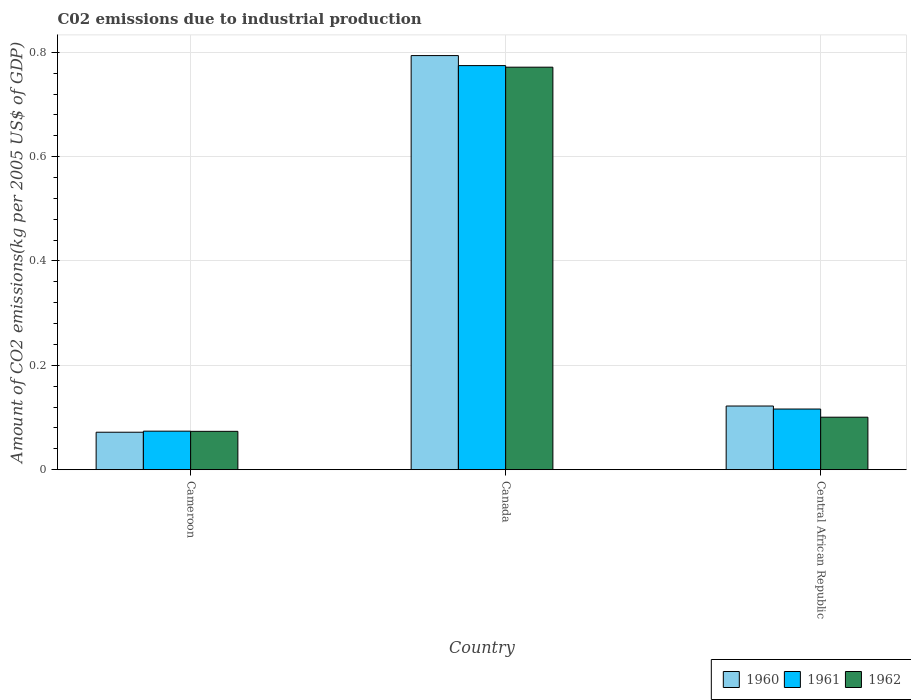How many different coloured bars are there?
Keep it short and to the point. 3. How many groups of bars are there?
Give a very brief answer. 3. How many bars are there on the 2nd tick from the right?
Offer a very short reply. 3. What is the label of the 1st group of bars from the left?
Your answer should be very brief. Cameroon. What is the amount of CO2 emitted due to industrial production in 1961 in Canada?
Your answer should be very brief. 0.77. Across all countries, what is the maximum amount of CO2 emitted due to industrial production in 1961?
Your answer should be compact. 0.77. Across all countries, what is the minimum amount of CO2 emitted due to industrial production in 1962?
Ensure brevity in your answer.  0.07. In which country was the amount of CO2 emitted due to industrial production in 1960 maximum?
Keep it short and to the point. Canada. In which country was the amount of CO2 emitted due to industrial production in 1962 minimum?
Your answer should be very brief. Cameroon. What is the total amount of CO2 emitted due to industrial production in 1961 in the graph?
Provide a short and direct response. 0.96. What is the difference between the amount of CO2 emitted due to industrial production in 1960 in Canada and that in Central African Republic?
Your answer should be compact. 0.67. What is the difference between the amount of CO2 emitted due to industrial production in 1962 in Central African Republic and the amount of CO2 emitted due to industrial production in 1960 in Canada?
Keep it short and to the point. -0.69. What is the average amount of CO2 emitted due to industrial production in 1961 per country?
Your answer should be compact. 0.32. What is the difference between the amount of CO2 emitted due to industrial production of/in 1960 and amount of CO2 emitted due to industrial production of/in 1961 in Central African Republic?
Offer a terse response. 0.01. In how many countries, is the amount of CO2 emitted due to industrial production in 1960 greater than 0.7200000000000001 kg?
Make the answer very short. 1. What is the ratio of the amount of CO2 emitted due to industrial production in 1960 in Cameroon to that in Central African Republic?
Offer a terse response. 0.59. What is the difference between the highest and the second highest amount of CO2 emitted due to industrial production in 1962?
Offer a very short reply. 0.7. What is the difference between the highest and the lowest amount of CO2 emitted due to industrial production in 1961?
Offer a terse response. 0.7. What does the 2nd bar from the left in Cameroon represents?
Give a very brief answer. 1961. What does the 1st bar from the right in Central African Republic represents?
Give a very brief answer. 1962. Are all the bars in the graph horizontal?
Offer a terse response. No. How many countries are there in the graph?
Offer a terse response. 3. What is the difference between two consecutive major ticks on the Y-axis?
Offer a very short reply. 0.2. Are the values on the major ticks of Y-axis written in scientific E-notation?
Keep it short and to the point. No. Does the graph contain any zero values?
Provide a short and direct response. No. Does the graph contain grids?
Your answer should be very brief. Yes. What is the title of the graph?
Your response must be concise. C02 emissions due to industrial production. What is the label or title of the Y-axis?
Provide a short and direct response. Amount of CO2 emissions(kg per 2005 US$ of GDP). What is the Amount of CO2 emissions(kg per 2005 US$ of GDP) of 1960 in Cameroon?
Offer a very short reply. 0.07. What is the Amount of CO2 emissions(kg per 2005 US$ of GDP) of 1961 in Cameroon?
Offer a very short reply. 0.07. What is the Amount of CO2 emissions(kg per 2005 US$ of GDP) in 1962 in Cameroon?
Ensure brevity in your answer.  0.07. What is the Amount of CO2 emissions(kg per 2005 US$ of GDP) in 1960 in Canada?
Keep it short and to the point. 0.79. What is the Amount of CO2 emissions(kg per 2005 US$ of GDP) in 1961 in Canada?
Ensure brevity in your answer.  0.77. What is the Amount of CO2 emissions(kg per 2005 US$ of GDP) of 1962 in Canada?
Ensure brevity in your answer.  0.77. What is the Amount of CO2 emissions(kg per 2005 US$ of GDP) in 1960 in Central African Republic?
Your answer should be very brief. 0.12. What is the Amount of CO2 emissions(kg per 2005 US$ of GDP) of 1961 in Central African Republic?
Ensure brevity in your answer.  0.12. What is the Amount of CO2 emissions(kg per 2005 US$ of GDP) of 1962 in Central African Republic?
Provide a succinct answer. 0.1. Across all countries, what is the maximum Amount of CO2 emissions(kg per 2005 US$ of GDP) in 1960?
Make the answer very short. 0.79. Across all countries, what is the maximum Amount of CO2 emissions(kg per 2005 US$ of GDP) in 1961?
Your answer should be very brief. 0.77. Across all countries, what is the maximum Amount of CO2 emissions(kg per 2005 US$ of GDP) of 1962?
Provide a succinct answer. 0.77. Across all countries, what is the minimum Amount of CO2 emissions(kg per 2005 US$ of GDP) of 1960?
Your answer should be very brief. 0.07. Across all countries, what is the minimum Amount of CO2 emissions(kg per 2005 US$ of GDP) of 1961?
Offer a very short reply. 0.07. Across all countries, what is the minimum Amount of CO2 emissions(kg per 2005 US$ of GDP) of 1962?
Offer a terse response. 0.07. What is the total Amount of CO2 emissions(kg per 2005 US$ of GDP) of 1960 in the graph?
Your answer should be compact. 0.99. What is the total Amount of CO2 emissions(kg per 2005 US$ of GDP) in 1961 in the graph?
Your answer should be compact. 0.96. What is the total Amount of CO2 emissions(kg per 2005 US$ of GDP) in 1962 in the graph?
Your response must be concise. 0.95. What is the difference between the Amount of CO2 emissions(kg per 2005 US$ of GDP) in 1960 in Cameroon and that in Canada?
Provide a short and direct response. -0.72. What is the difference between the Amount of CO2 emissions(kg per 2005 US$ of GDP) of 1961 in Cameroon and that in Canada?
Offer a very short reply. -0.7. What is the difference between the Amount of CO2 emissions(kg per 2005 US$ of GDP) of 1962 in Cameroon and that in Canada?
Offer a very short reply. -0.7. What is the difference between the Amount of CO2 emissions(kg per 2005 US$ of GDP) of 1960 in Cameroon and that in Central African Republic?
Provide a short and direct response. -0.05. What is the difference between the Amount of CO2 emissions(kg per 2005 US$ of GDP) of 1961 in Cameroon and that in Central African Republic?
Provide a succinct answer. -0.04. What is the difference between the Amount of CO2 emissions(kg per 2005 US$ of GDP) in 1962 in Cameroon and that in Central African Republic?
Keep it short and to the point. -0.03. What is the difference between the Amount of CO2 emissions(kg per 2005 US$ of GDP) in 1960 in Canada and that in Central African Republic?
Make the answer very short. 0.67. What is the difference between the Amount of CO2 emissions(kg per 2005 US$ of GDP) in 1961 in Canada and that in Central African Republic?
Offer a terse response. 0.66. What is the difference between the Amount of CO2 emissions(kg per 2005 US$ of GDP) in 1962 in Canada and that in Central African Republic?
Your answer should be compact. 0.67. What is the difference between the Amount of CO2 emissions(kg per 2005 US$ of GDP) of 1960 in Cameroon and the Amount of CO2 emissions(kg per 2005 US$ of GDP) of 1961 in Canada?
Offer a terse response. -0.7. What is the difference between the Amount of CO2 emissions(kg per 2005 US$ of GDP) of 1960 in Cameroon and the Amount of CO2 emissions(kg per 2005 US$ of GDP) of 1962 in Canada?
Your answer should be compact. -0.7. What is the difference between the Amount of CO2 emissions(kg per 2005 US$ of GDP) in 1961 in Cameroon and the Amount of CO2 emissions(kg per 2005 US$ of GDP) in 1962 in Canada?
Offer a terse response. -0.7. What is the difference between the Amount of CO2 emissions(kg per 2005 US$ of GDP) of 1960 in Cameroon and the Amount of CO2 emissions(kg per 2005 US$ of GDP) of 1961 in Central African Republic?
Provide a short and direct response. -0.04. What is the difference between the Amount of CO2 emissions(kg per 2005 US$ of GDP) in 1960 in Cameroon and the Amount of CO2 emissions(kg per 2005 US$ of GDP) in 1962 in Central African Republic?
Keep it short and to the point. -0.03. What is the difference between the Amount of CO2 emissions(kg per 2005 US$ of GDP) in 1961 in Cameroon and the Amount of CO2 emissions(kg per 2005 US$ of GDP) in 1962 in Central African Republic?
Make the answer very short. -0.03. What is the difference between the Amount of CO2 emissions(kg per 2005 US$ of GDP) in 1960 in Canada and the Amount of CO2 emissions(kg per 2005 US$ of GDP) in 1961 in Central African Republic?
Keep it short and to the point. 0.68. What is the difference between the Amount of CO2 emissions(kg per 2005 US$ of GDP) in 1960 in Canada and the Amount of CO2 emissions(kg per 2005 US$ of GDP) in 1962 in Central African Republic?
Offer a terse response. 0.69. What is the difference between the Amount of CO2 emissions(kg per 2005 US$ of GDP) of 1961 in Canada and the Amount of CO2 emissions(kg per 2005 US$ of GDP) of 1962 in Central African Republic?
Ensure brevity in your answer.  0.67. What is the average Amount of CO2 emissions(kg per 2005 US$ of GDP) in 1960 per country?
Provide a succinct answer. 0.33. What is the average Amount of CO2 emissions(kg per 2005 US$ of GDP) in 1961 per country?
Ensure brevity in your answer.  0.32. What is the average Amount of CO2 emissions(kg per 2005 US$ of GDP) in 1962 per country?
Offer a terse response. 0.32. What is the difference between the Amount of CO2 emissions(kg per 2005 US$ of GDP) of 1960 and Amount of CO2 emissions(kg per 2005 US$ of GDP) of 1961 in Cameroon?
Your answer should be compact. -0. What is the difference between the Amount of CO2 emissions(kg per 2005 US$ of GDP) of 1960 and Amount of CO2 emissions(kg per 2005 US$ of GDP) of 1962 in Cameroon?
Your answer should be compact. -0. What is the difference between the Amount of CO2 emissions(kg per 2005 US$ of GDP) of 1961 and Amount of CO2 emissions(kg per 2005 US$ of GDP) of 1962 in Cameroon?
Provide a short and direct response. 0. What is the difference between the Amount of CO2 emissions(kg per 2005 US$ of GDP) of 1960 and Amount of CO2 emissions(kg per 2005 US$ of GDP) of 1961 in Canada?
Give a very brief answer. 0.02. What is the difference between the Amount of CO2 emissions(kg per 2005 US$ of GDP) of 1960 and Amount of CO2 emissions(kg per 2005 US$ of GDP) of 1962 in Canada?
Your response must be concise. 0.02. What is the difference between the Amount of CO2 emissions(kg per 2005 US$ of GDP) of 1961 and Amount of CO2 emissions(kg per 2005 US$ of GDP) of 1962 in Canada?
Your answer should be compact. 0. What is the difference between the Amount of CO2 emissions(kg per 2005 US$ of GDP) in 1960 and Amount of CO2 emissions(kg per 2005 US$ of GDP) in 1961 in Central African Republic?
Provide a short and direct response. 0.01. What is the difference between the Amount of CO2 emissions(kg per 2005 US$ of GDP) in 1960 and Amount of CO2 emissions(kg per 2005 US$ of GDP) in 1962 in Central African Republic?
Offer a terse response. 0.02. What is the difference between the Amount of CO2 emissions(kg per 2005 US$ of GDP) in 1961 and Amount of CO2 emissions(kg per 2005 US$ of GDP) in 1962 in Central African Republic?
Offer a very short reply. 0.02. What is the ratio of the Amount of CO2 emissions(kg per 2005 US$ of GDP) of 1960 in Cameroon to that in Canada?
Keep it short and to the point. 0.09. What is the ratio of the Amount of CO2 emissions(kg per 2005 US$ of GDP) in 1961 in Cameroon to that in Canada?
Provide a short and direct response. 0.1. What is the ratio of the Amount of CO2 emissions(kg per 2005 US$ of GDP) of 1962 in Cameroon to that in Canada?
Offer a very short reply. 0.1. What is the ratio of the Amount of CO2 emissions(kg per 2005 US$ of GDP) of 1960 in Cameroon to that in Central African Republic?
Your response must be concise. 0.59. What is the ratio of the Amount of CO2 emissions(kg per 2005 US$ of GDP) of 1961 in Cameroon to that in Central African Republic?
Offer a very short reply. 0.64. What is the ratio of the Amount of CO2 emissions(kg per 2005 US$ of GDP) in 1962 in Cameroon to that in Central African Republic?
Ensure brevity in your answer.  0.73. What is the ratio of the Amount of CO2 emissions(kg per 2005 US$ of GDP) of 1960 in Canada to that in Central African Republic?
Your answer should be compact. 6.5. What is the ratio of the Amount of CO2 emissions(kg per 2005 US$ of GDP) of 1961 in Canada to that in Central African Republic?
Keep it short and to the point. 6.66. What is the ratio of the Amount of CO2 emissions(kg per 2005 US$ of GDP) of 1962 in Canada to that in Central African Republic?
Keep it short and to the point. 7.67. What is the difference between the highest and the second highest Amount of CO2 emissions(kg per 2005 US$ of GDP) of 1960?
Your answer should be compact. 0.67. What is the difference between the highest and the second highest Amount of CO2 emissions(kg per 2005 US$ of GDP) of 1961?
Make the answer very short. 0.66. What is the difference between the highest and the second highest Amount of CO2 emissions(kg per 2005 US$ of GDP) in 1962?
Your answer should be compact. 0.67. What is the difference between the highest and the lowest Amount of CO2 emissions(kg per 2005 US$ of GDP) of 1960?
Ensure brevity in your answer.  0.72. What is the difference between the highest and the lowest Amount of CO2 emissions(kg per 2005 US$ of GDP) in 1961?
Your answer should be compact. 0.7. What is the difference between the highest and the lowest Amount of CO2 emissions(kg per 2005 US$ of GDP) in 1962?
Make the answer very short. 0.7. 